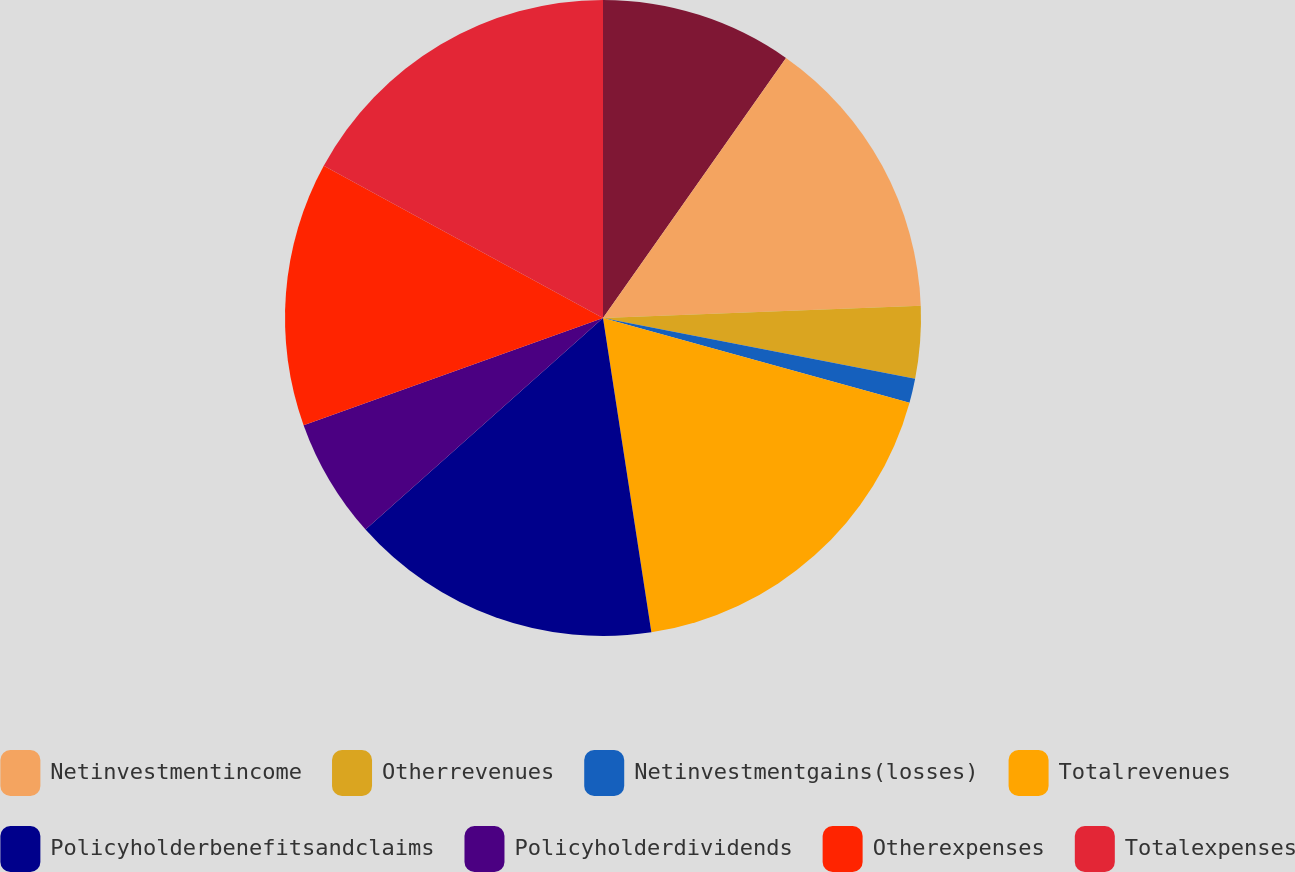Convert chart. <chart><loc_0><loc_0><loc_500><loc_500><pie_chart><ecel><fcel>Netinvestmentincome<fcel>Otherrevenues<fcel>Netinvestmentgains(losses)<fcel>Totalrevenues<fcel>Policyholderbenefitsandclaims<fcel>Policyholderdividends<fcel>Otherexpenses<fcel>Totalexpenses<nl><fcel>9.76%<fcel>14.63%<fcel>3.67%<fcel>1.23%<fcel>18.28%<fcel>15.85%<fcel>6.11%<fcel>13.41%<fcel>17.06%<nl></chart> 